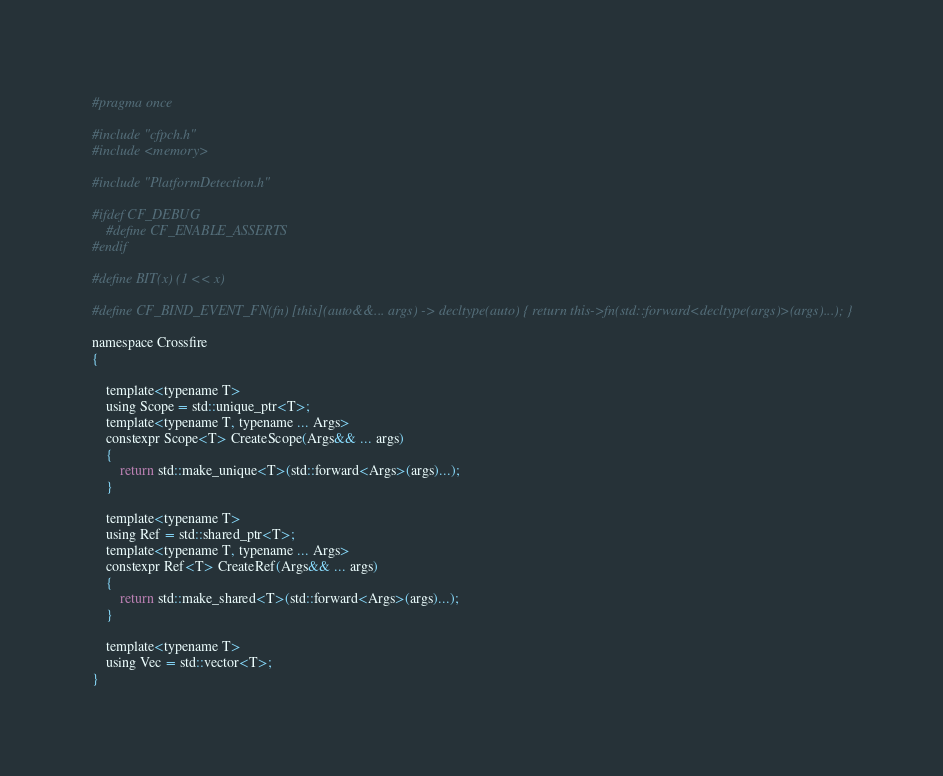Convert code to text. <code><loc_0><loc_0><loc_500><loc_500><_C_>#pragma once

#include "cfpch.h"
#include <memory>

#include "PlatformDetection.h"

#ifdef CF_DEBUG
	#define CF_ENABLE_ASSERTS
#endif

#define BIT(x) (1 << x)

#define CF_BIND_EVENT_FN(fn) [this](auto&&... args) -> decltype(auto) { return this->fn(std::forward<decltype(args)>(args)...); }

namespace Crossfire
{

	template<typename T>
	using Scope = std::unique_ptr<T>;
	template<typename T, typename ... Args>
	constexpr Scope<T> CreateScope(Args&& ... args)
	{
		return std::make_unique<T>(std::forward<Args>(args)...);
	}

	template<typename T>
	using Ref = std::shared_ptr<T>;
	template<typename T, typename ... Args>
	constexpr Ref<T> CreateRef(Args&& ... args)
	{
		return std::make_shared<T>(std::forward<Args>(args)...);
	}

	template<typename T>
	using Vec = std::vector<T>;
}</code> 